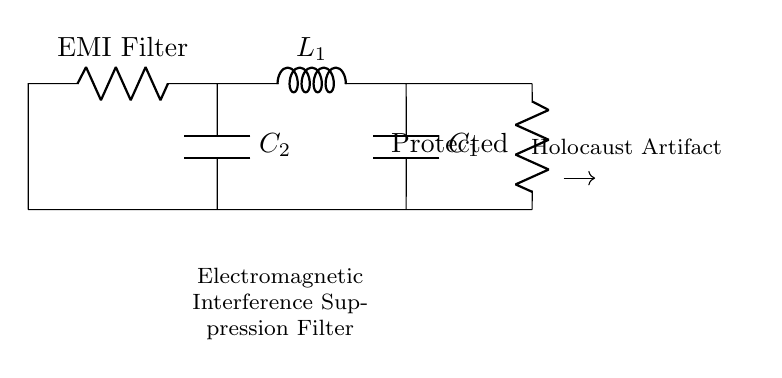What components are present in this circuit? The components visible in the circuit include two resistors, one inductor, and two capacitors. Specifically, they are labeled as EMI Filter, R_load, L1, C1, and C2.
Answer: Two resistors, one inductor, two capacitors What is the purpose of the EMI Filter in this circuit? The EMI Filter is designed to suppress electromagnetic interference which can harm sensitive artifacts, like those from the Holocaust, by filtering out unwanted signals.
Answer: Suppress electromagnetic interference How many capacitors are in this circuit? By examining the diagram, we can see two capacitors are present, labeled C1 and C2.
Answer: Two capacitors What forms the load in this circuit? The load in this circuit is represented by the component labeled R_load, which protects the connected artifact from interference.
Answer: R_load What types of components are shown in series versus parallel in this circuit? The circuit has resistors and inductors typically arranged in series while capacitors are likely in parallel configuration, which helps in current division across multiple paths.
Answer: Resistors and inductors in series; capacitors in parallel What is the importance of the inductor in the context of this circuit? The inductor helps to resist changes in current, which aids in filtering unwanted high-frequency signals that could damage delicate artifacts.
Answer: Filter unwanted high-frequency signals 